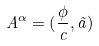Convert formula to latex. <formula><loc_0><loc_0><loc_500><loc_500>A ^ { \alpha } = ( \frac { \phi } { c } , \vec { a } )</formula> 